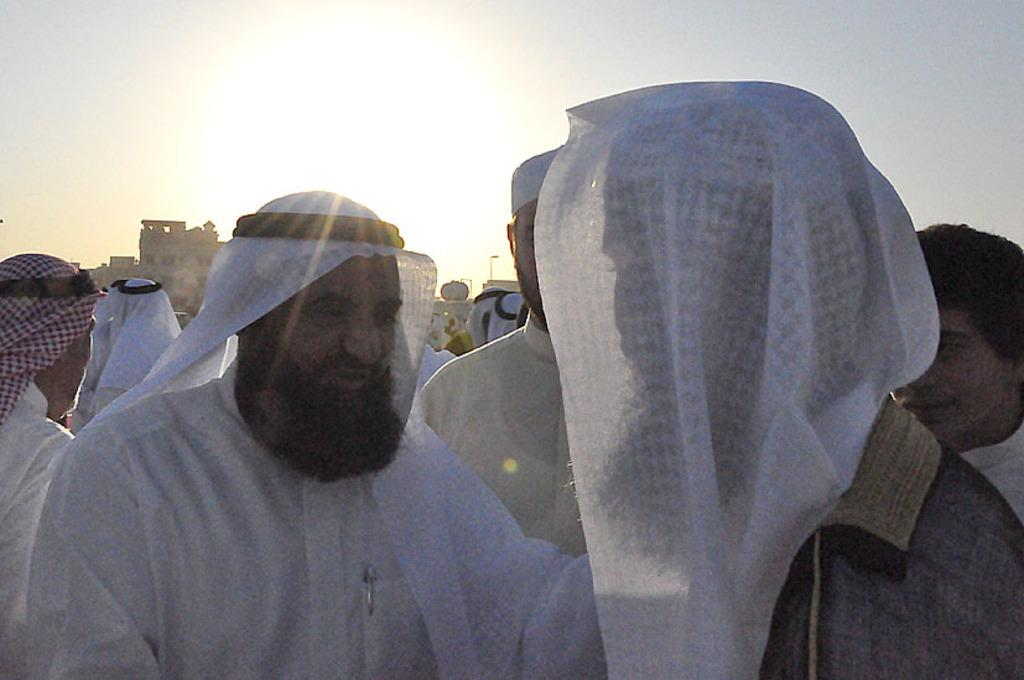How many people are in the image? There is a group of people in the image, but the exact number is not specified. What can be seen in the background of the image? There are buildings and the sky visible in the background of the image. What type of company is represented by the plane in the image? There is no plane present in the image, so it is not possible to determine the type of company it might represent. 